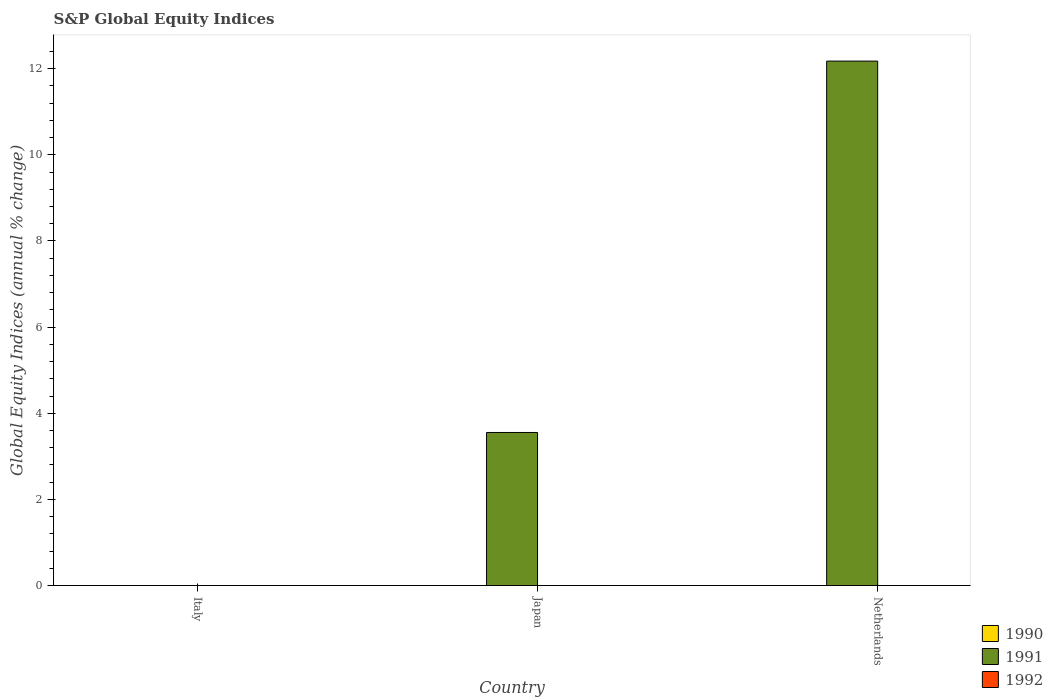Are the number of bars per tick equal to the number of legend labels?
Provide a short and direct response. No. Are the number of bars on each tick of the X-axis equal?
Your response must be concise. No. In how many cases, is the number of bars for a given country not equal to the number of legend labels?
Keep it short and to the point. 3. What is the global equity indices in 1991 in Japan?
Offer a terse response. 3.55. Across all countries, what is the maximum global equity indices in 1991?
Ensure brevity in your answer.  12.18. In which country was the global equity indices in 1991 maximum?
Provide a succinct answer. Netherlands. What is the total global equity indices in 1991 in the graph?
Your answer should be compact. 15.73. What is the difference between the global equity indices in 1991 in Japan and that in Netherlands?
Your answer should be very brief. -8.62. What is the difference between the global equity indices in 1992 in Japan and the global equity indices in 1991 in Netherlands?
Your response must be concise. -12.18. What is the average global equity indices in 1992 per country?
Your answer should be compact. 0. In how many countries, is the global equity indices in 1991 greater than 7.6 %?
Offer a very short reply. 1. What is the difference between the highest and the lowest global equity indices in 1991?
Offer a terse response. 12.18. In how many countries, is the global equity indices in 1991 greater than the average global equity indices in 1991 taken over all countries?
Ensure brevity in your answer.  1. What is the difference between two consecutive major ticks on the Y-axis?
Your answer should be compact. 2. Does the graph contain any zero values?
Offer a terse response. Yes. Does the graph contain grids?
Ensure brevity in your answer.  No. What is the title of the graph?
Provide a short and direct response. S&P Global Equity Indices. Does "2003" appear as one of the legend labels in the graph?
Make the answer very short. No. What is the label or title of the X-axis?
Make the answer very short. Country. What is the label or title of the Y-axis?
Ensure brevity in your answer.  Global Equity Indices (annual % change). What is the Global Equity Indices (annual % change) in 1991 in Italy?
Ensure brevity in your answer.  0. What is the Global Equity Indices (annual % change) in 1990 in Japan?
Your response must be concise. 0. What is the Global Equity Indices (annual % change) in 1991 in Japan?
Your answer should be very brief. 3.55. What is the Global Equity Indices (annual % change) of 1992 in Japan?
Offer a very short reply. 0. What is the Global Equity Indices (annual % change) of 1990 in Netherlands?
Provide a short and direct response. 0. What is the Global Equity Indices (annual % change) in 1991 in Netherlands?
Provide a succinct answer. 12.18. Across all countries, what is the maximum Global Equity Indices (annual % change) in 1991?
Your answer should be very brief. 12.18. Across all countries, what is the minimum Global Equity Indices (annual % change) in 1991?
Provide a short and direct response. 0. What is the total Global Equity Indices (annual % change) in 1990 in the graph?
Keep it short and to the point. 0. What is the total Global Equity Indices (annual % change) of 1991 in the graph?
Offer a very short reply. 15.73. What is the total Global Equity Indices (annual % change) of 1992 in the graph?
Provide a short and direct response. 0. What is the difference between the Global Equity Indices (annual % change) in 1991 in Japan and that in Netherlands?
Offer a terse response. -8.62. What is the average Global Equity Indices (annual % change) of 1990 per country?
Your answer should be compact. 0. What is the average Global Equity Indices (annual % change) of 1991 per country?
Offer a terse response. 5.24. What is the ratio of the Global Equity Indices (annual % change) of 1991 in Japan to that in Netherlands?
Your answer should be very brief. 0.29. What is the difference between the highest and the lowest Global Equity Indices (annual % change) of 1991?
Your answer should be very brief. 12.18. 